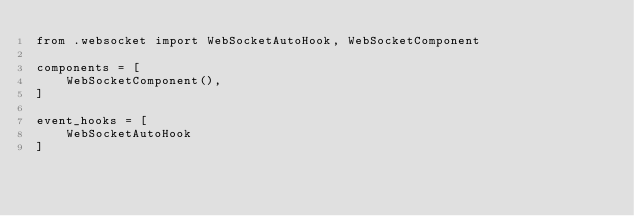<code> <loc_0><loc_0><loc_500><loc_500><_Python_>from .websocket import WebSocketAutoHook, WebSocketComponent

components = [
    WebSocketComponent(),
]

event_hooks = [
    WebSocketAutoHook
]
</code> 